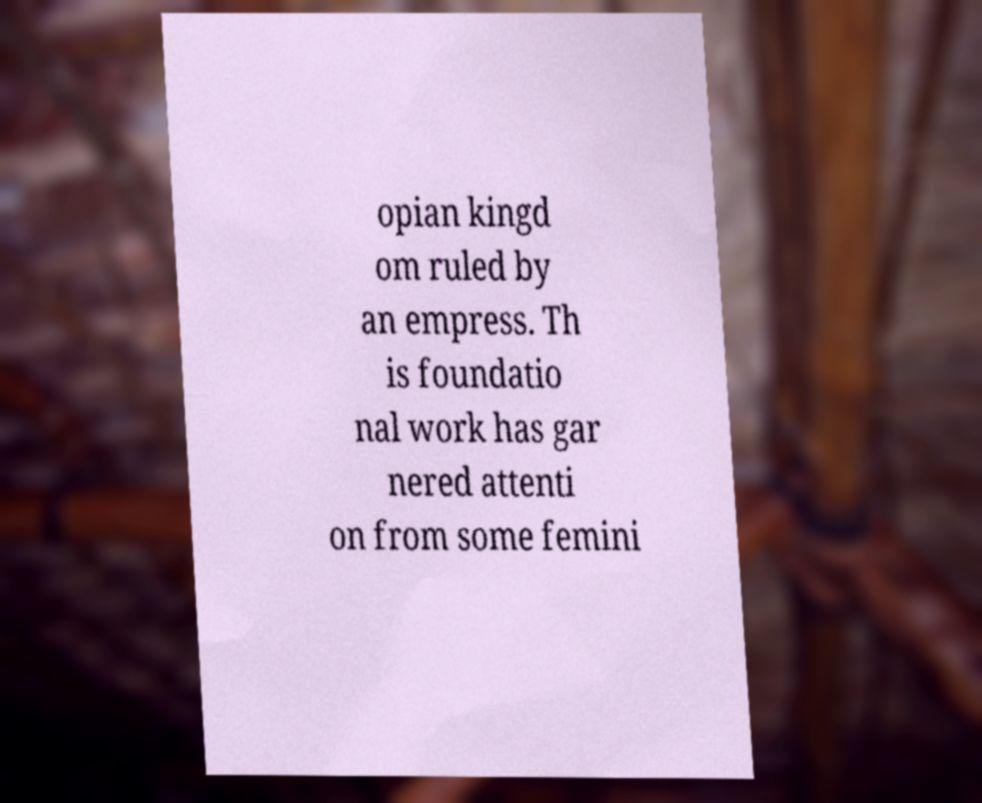Please read and relay the text visible in this image. What does it say? opian kingd om ruled by an empress. Th is foundatio nal work has gar nered attenti on from some femini 